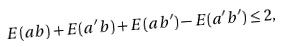Convert formula to latex. <formula><loc_0><loc_0><loc_500><loc_500>E ( a b ) + E ( a ^ { \prime } b ) + E ( a b ^ { \prime } ) - E ( a ^ { \prime } b ^ { \prime } ) \leq 2 ,</formula> 